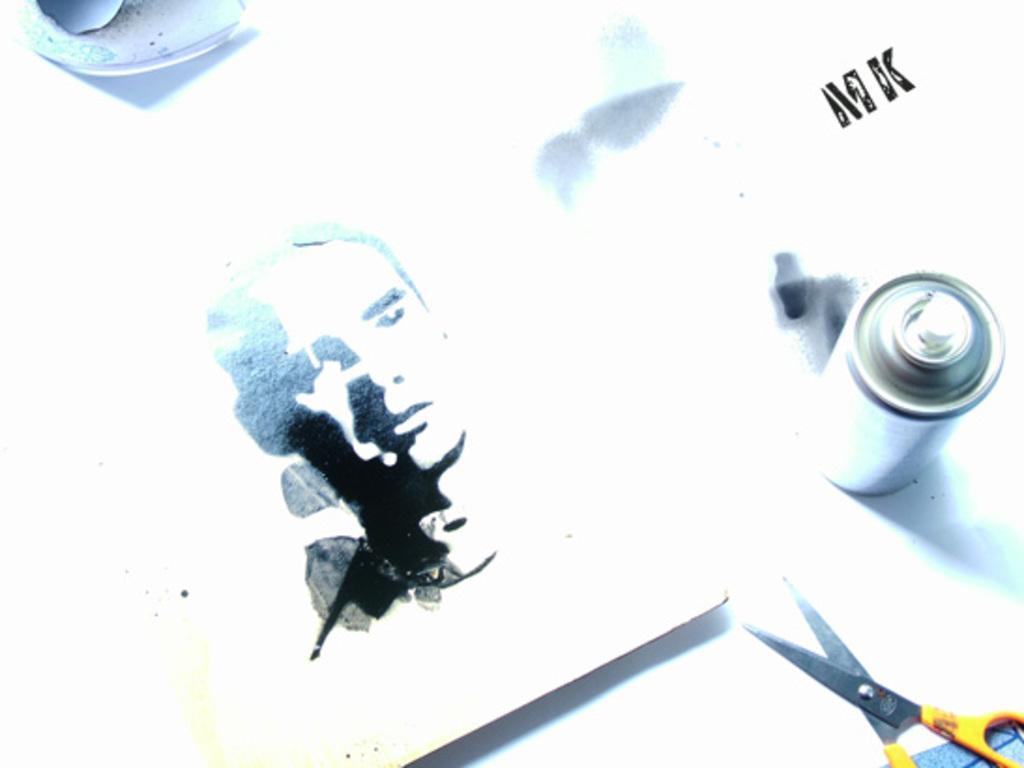In one or two sentences, can you explain what this image depicts? In this image there is a scissor, there is a spray tan and there is the image of the person and there is some text written on the image and on the top left there is an object which is white and grey in colour. 